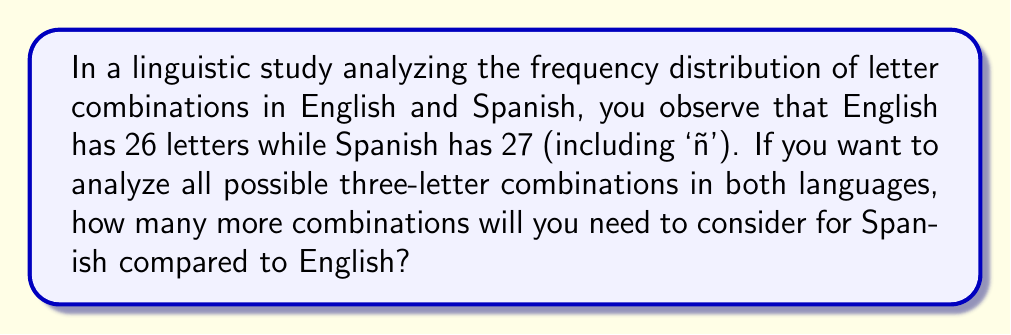Give your solution to this math problem. Let's approach this step-by-step:

1) First, we need to calculate the number of possible three-letter combinations for each language.

2) For English:
   - Number of letters = 26
   - We're selecting 3 letters with replacement (as letters can repeat)
   - The formula for this is $n^r$, where $n$ is the number of options and $r$ is the number of selections
   - So, for English: $26^3 = 17,576$ combinations

3) For Spanish:
   - Number of letters = 27
   - Using the same formula: $27^3 = 19,683$ combinations

4) To find how many more combinations Spanish has:
   $19,683 - 17,576 = 2,107$

Therefore, when analyzing three-letter combinations, you'll need to consider 2,107 more combinations for Spanish than for English.
Answer: 2,107 